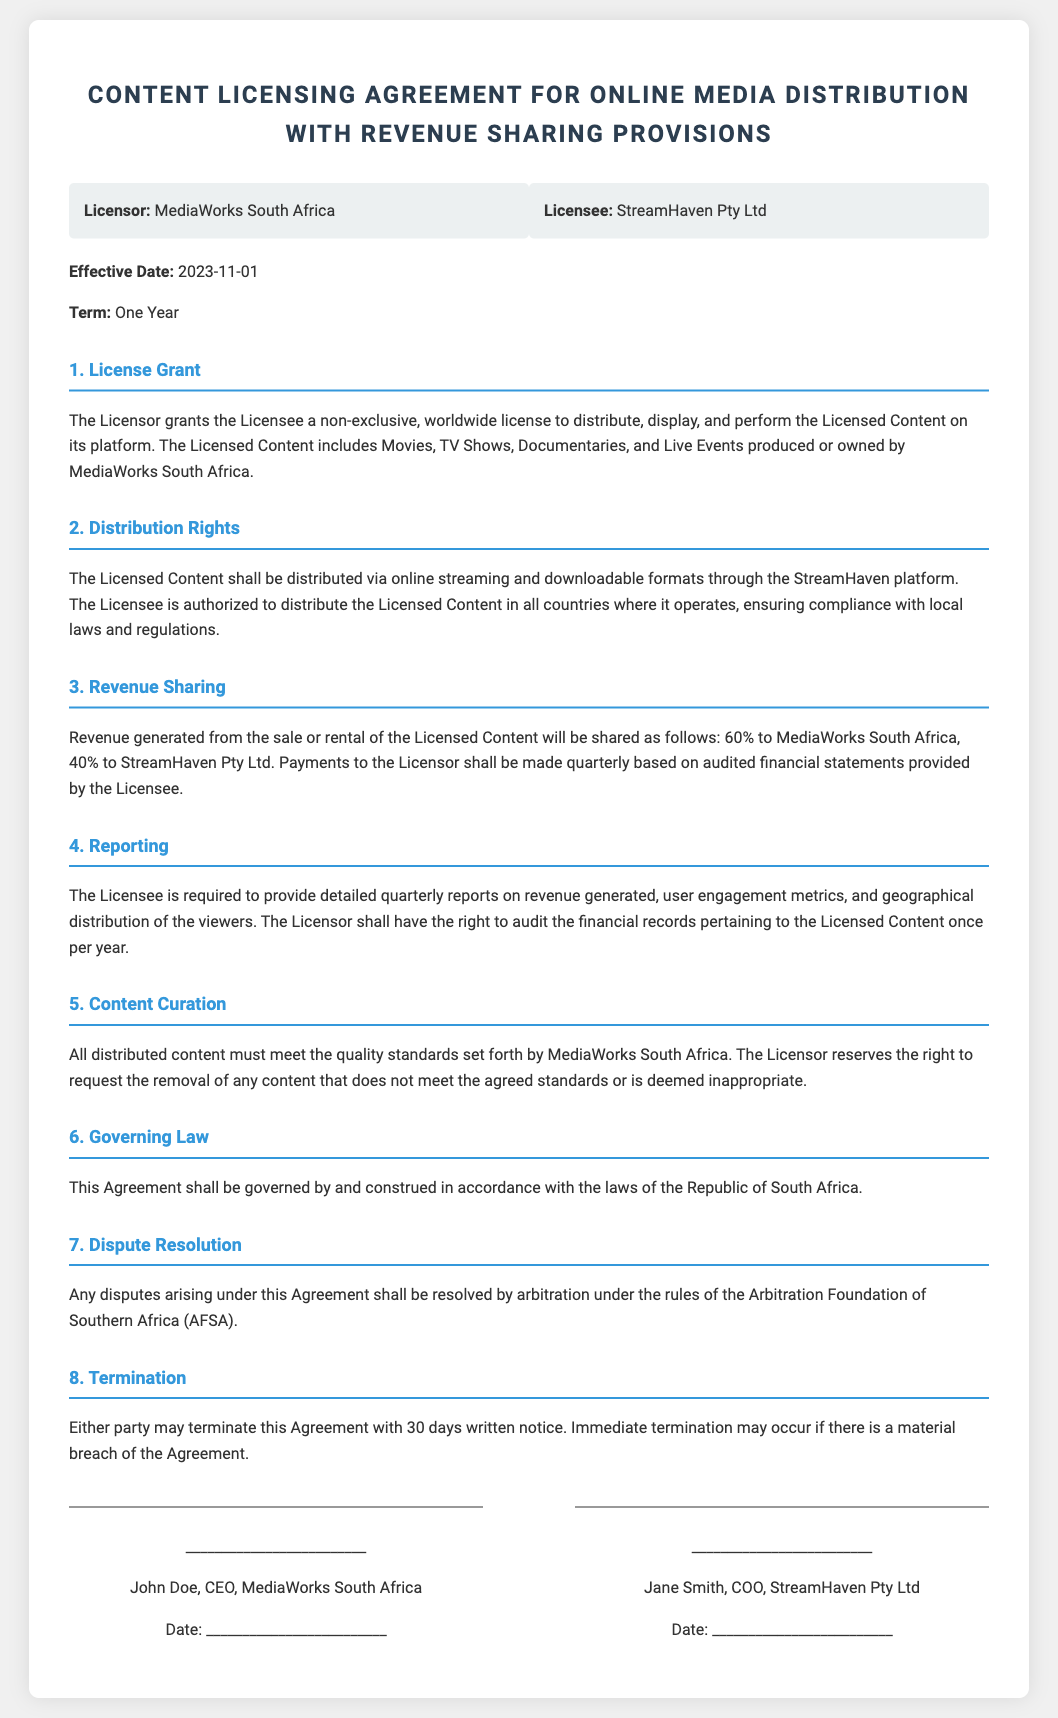what is the effective date of the agreement? The effective date is specified in the document as the date when the agreement starts, which is stated explicitly.
Answer: 2023-11-01 who is the licensor in this agreement? The licensor is the party granting the license, and the document identifies MediaWorks South Africa as the licensor.
Answer: MediaWorks South Africa what percentage of revenue will MediaWorks receive? The revenue sharing clause provides the specific split, making it clear how the revenue is distributed.
Answer: 60% how long is the term of the license agreement? The term is mentioned clearly in the document, indicating how long the agreement is valid.
Answer: One Year what rights does the licensee have regarding distribution? The distribution rights are outlined, detailing the extent of the licensee's permissions under the agreement.
Answer: non-exclusive, worldwide license what is required from the licensee in terms of reporting? The document specifies what kind of information needs to be reported by the licensee to the licensor.
Answer: detailed quarterly reports how can either party terminate the agreement? The termination clause explains the process and conditions under which the agreement can be ended by either party.
Answer: 30 days written notice what entity governs the agreement? The governing law section specifies the legal framework applicable to the agreement, indicating which jurisdiction's laws are relevant.
Answer: Republic of South Africa what is the dispute resolution mechanism mentioned? The dispute resolution section of the document indicates how conflicts will be handled legally, which is an essential contractual element.
Answer: arbitration under the rules of AFSA 